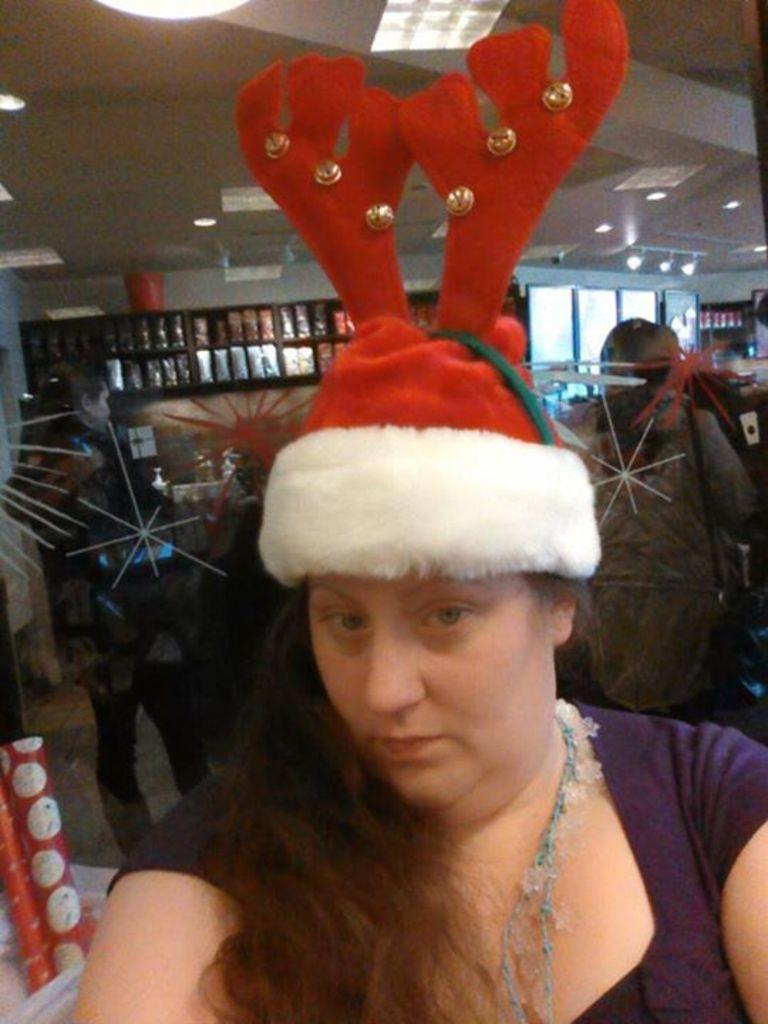Who is the main subject in the image? The main subject in the image is a woman. What is the woman doing in the image? The woman is standing in the image. What is the woman holding in the image? The woman is holding a red color cap. What is the woman wearing in the image? The woman is wearing a red color cap. What can be seen in the background of the image? There are people in the backdrop of the image. What type of locket is the woman wearing in the image? There is no locket visible in the image; the woman is wearing a red color cap. 